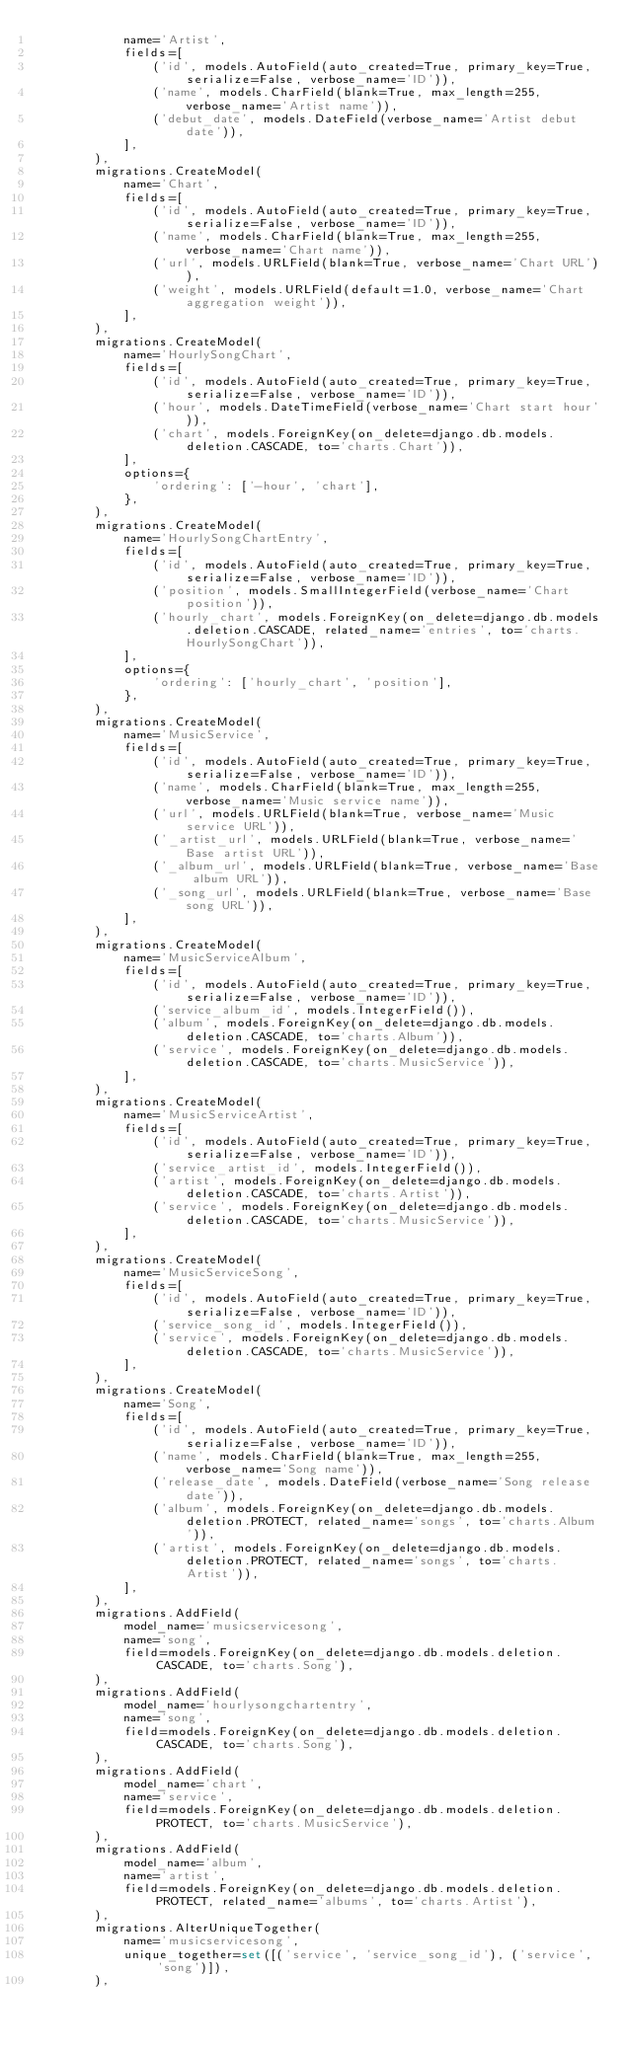<code> <loc_0><loc_0><loc_500><loc_500><_Python_>            name='Artist',
            fields=[
                ('id', models.AutoField(auto_created=True, primary_key=True, serialize=False, verbose_name='ID')),
                ('name', models.CharField(blank=True, max_length=255, verbose_name='Artist name')),
                ('debut_date', models.DateField(verbose_name='Artist debut date')),
            ],
        ),
        migrations.CreateModel(
            name='Chart',
            fields=[
                ('id', models.AutoField(auto_created=True, primary_key=True, serialize=False, verbose_name='ID')),
                ('name', models.CharField(blank=True, max_length=255, verbose_name='Chart name')),
                ('url', models.URLField(blank=True, verbose_name='Chart URL')),
                ('weight', models.URLField(default=1.0, verbose_name='Chart aggregation weight')),
            ],
        ),
        migrations.CreateModel(
            name='HourlySongChart',
            fields=[
                ('id', models.AutoField(auto_created=True, primary_key=True, serialize=False, verbose_name='ID')),
                ('hour', models.DateTimeField(verbose_name='Chart start hour')),
                ('chart', models.ForeignKey(on_delete=django.db.models.deletion.CASCADE, to='charts.Chart')),
            ],
            options={
                'ordering': ['-hour', 'chart'],
            },
        ),
        migrations.CreateModel(
            name='HourlySongChartEntry',
            fields=[
                ('id', models.AutoField(auto_created=True, primary_key=True, serialize=False, verbose_name='ID')),
                ('position', models.SmallIntegerField(verbose_name='Chart position')),
                ('hourly_chart', models.ForeignKey(on_delete=django.db.models.deletion.CASCADE, related_name='entries', to='charts.HourlySongChart')),
            ],
            options={
                'ordering': ['hourly_chart', 'position'],
            },
        ),
        migrations.CreateModel(
            name='MusicService',
            fields=[
                ('id', models.AutoField(auto_created=True, primary_key=True, serialize=False, verbose_name='ID')),
                ('name', models.CharField(blank=True, max_length=255, verbose_name='Music service name')),
                ('url', models.URLField(blank=True, verbose_name='Music service URL')),
                ('_artist_url', models.URLField(blank=True, verbose_name='Base artist URL')),
                ('_album_url', models.URLField(blank=True, verbose_name='Base album URL')),
                ('_song_url', models.URLField(blank=True, verbose_name='Base song URL')),
            ],
        ),
        migrations.CreateModel(
            name='MusicServiceAlbum',
            fields=[
                ('id', models.AutoField(auto_created=True, primary_key=True, serialize=False, verbose_name='ID')),
                ('service_album_id', models.IntegerField()),
                ('album', models.ForeignKey(on_delete=django.db.models.deletion.CASCADE, to='charts.Album')),
                ('service', models.ForeignKey(on_delete=django.db.models.deletion.CASCADE, to='charts.MusicService')),
            ],
        ),
        migrations.CreateModel(
            name='MusicServiceArtist',
            fields=[
                ('id', models.AutoField(auto_created=True, primary_key=True, serialize=False, verbose_name='ID')),
                ('service_artist_id', models.IntegerField()),
                ('artist', models.ForeignKey(on_delete=django.db.models.deletion.CASCADE, to='charts.Artist')),
                ('service', models.ForeignKey(on_delete=django.db.models.deletion.CASCADE, to='charts.MusicService')),
            ],
        ),
        migrations.CreateModel(
            name='MusicServiceSong',
            fields=[
                ('id', models.AutoField(auto_created=True, primary_key=True, serialize=False, verbose_name='ID')),
                ('service_song_id', models.IntegerField()),
                ('service', models.ForeignKey(on_delete=django.db.models.deletion.CASCADE, to='charts.MusicService')),
            ],
        ),
        migrations.CreateModel(
            name='Song',
            fields=[
                ('id', models.AutoField(auto_created=True, primary_key=True, serialize=False, verbose_name='ID')),
                ('name', models.CharField(blank=True, max_length=255, verbose_name='Song name')),
                ('release_date', models.DateField(verbose_name='Song release date')),
                ('album', models.ForeignKey(on_delete=django.db.models.deletion.PROTECT, related_name='songs', to='charts.Album')),
                ('artist', models.ForeignKey(on_delete=django.db.models.deletion.PROTECT, related_name='songs', to='charts.Artist')),
            ],
        ),
        migrations.AddField(
            model_name='musicservicesong',
            name='song',
            field=models.ForeignKey(on_delete=django.db.models.deletion.CASCADE, to='charts.Song'),
        ),
        migrations.AddField(
            model_name='hourlysongchartentry',
            name='song',
            field=models.ForeignKey(on_delete=django.db.models.deletion.CASCADE, to='charts.Song'),
        ),
        migrations.AddField(
            model_name='chart',
            name='service',
            field=models.ForeignKey(on_delete=django.db.models.deletion.PROTECT, to='charts.MusicService'),
        ),
        migrations.AddField(
            model_name='album',
            name='artist',
            field=models.ForeignKey(on_delete=django.db.models.deletion.PROTECT, related_name='albums', to='charts.Artist'),
        ),
        migrations.AlterUniqueTogether(
            name='musicservicesong',
            unique_together=set([('service', 'service_song_id'), ('service', 'song')]),
        ),</code> 